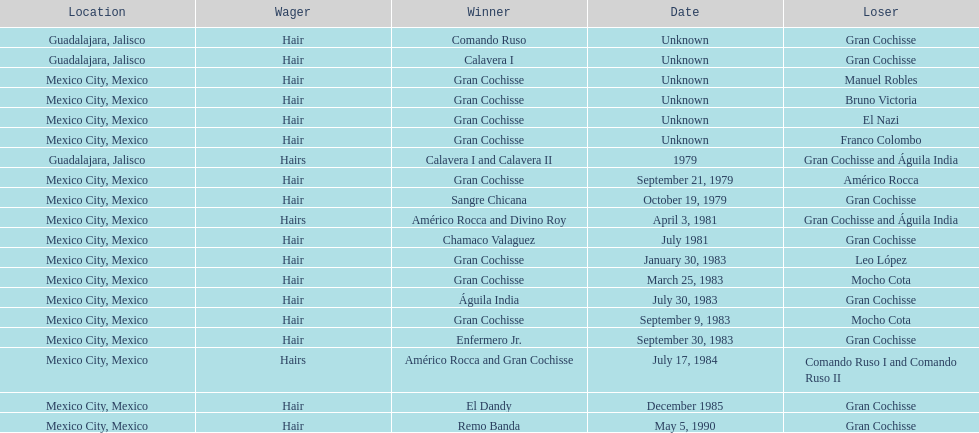How many winners were there before bruno victoria lost? 3. 